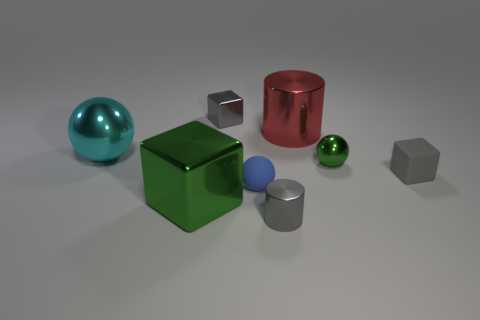Add 1 small yellow spheres. How many objects exist? 9 Subtract all cubes. How many objects are left? 5 Subtract 1 red cylinders. How many objects are left? 7 Subtract all small blue matte cylinders. Subtract all big spheres. How many objects are left? 7 Add 8 gray cubes. How many gray cubes are left? 10 Add 6 tiny gray cylinders. How many tiny gray cylinders exist? 7 